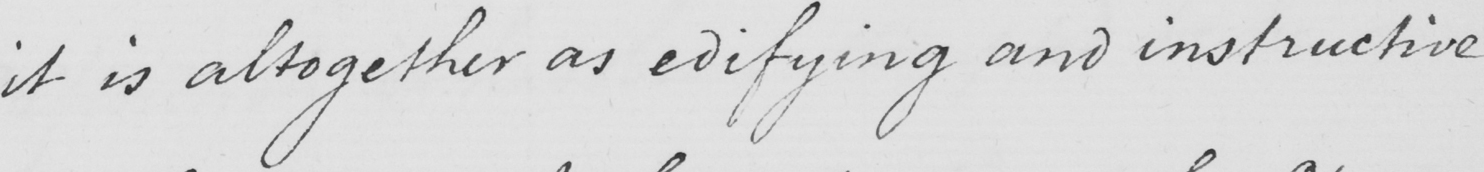What is written in this line of handwriting? it is altogether as edifying and instructive 